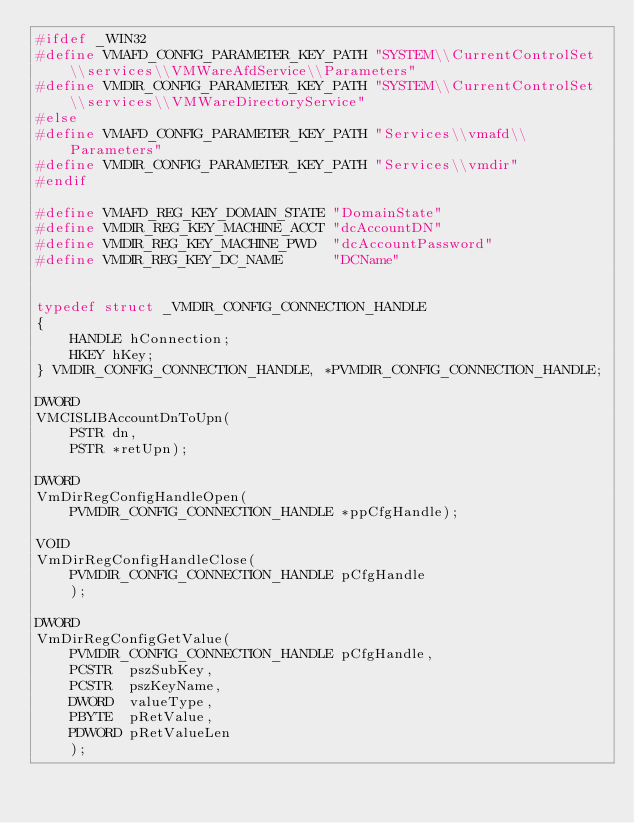<code> <loc_0><loc_0><loc_500><loc_500><_C_>#ifdef _WIN32
#define VMAFD_CONFIG_PARAMETER_KEY_PATH "SYSTEM\\CurrentControlSet\\services\\VMWareAfdService\\Parameters"
#define VMDIR_CONFIG_PARAMETER_KEY_PATH "SYSTEM\\CurrentControlSet\\services\\VMWareDirectoryService"
#else
#define VMAFD_CONFIG_PARAMETER_KEY_PATH "Services\\vmafd\\Parameters"
#define VMDIR_CONFIG_PARAMETER_KEY_PATH "Services\\vmdir"
#endif

#define VMAFD_REG_KEY_DOMAIN_STATE "DomainState"
#define VMDIR_REG_KEY_MACHINE_ACCT "dcAccountDN"
#define VMDIR_REG_KEY_MACHINE_PWD  "dcAccountPassword"
#define VMDIR_REG_KEY_DC_NAME      "DCName"


typedef struct _VMDIR_CONFIG_CONNECTION_HANDLE
{
    HANDLE hConnection;
    HKEY hKey;
} VMDIR_CONFIG_CONNECTION_HANDLE, *PVMDIR_CONFIG_CONNECTION_HANDLE;

DWORD
VMCISLIBAccountDnToUpn(
    PSTR dn,
    PSTR *retUpn);

DWORD
VmDirRegConfigHandleOpen(
    PVMDIR_CONFIG_CONNECTION_HANDLE *ppCfgHandle);

VOID
VmDirRegConfigHandleClose(
    PVMDIR_CONFIG_CONNECTION_HANDLE pCfgHandle
    );

DWORD
VmDirRegConfigGetValue(
    PVMDIR_CONFIG_CONNECTION_HANDLE pCfgHandle,
    PCSTR  pszSubKey,
    PCSTR  pszKeyName,
    DWORD  valueType,
    PBYTE  pRetValue,
    PDWORD pRetValueLen
    );
</code> 